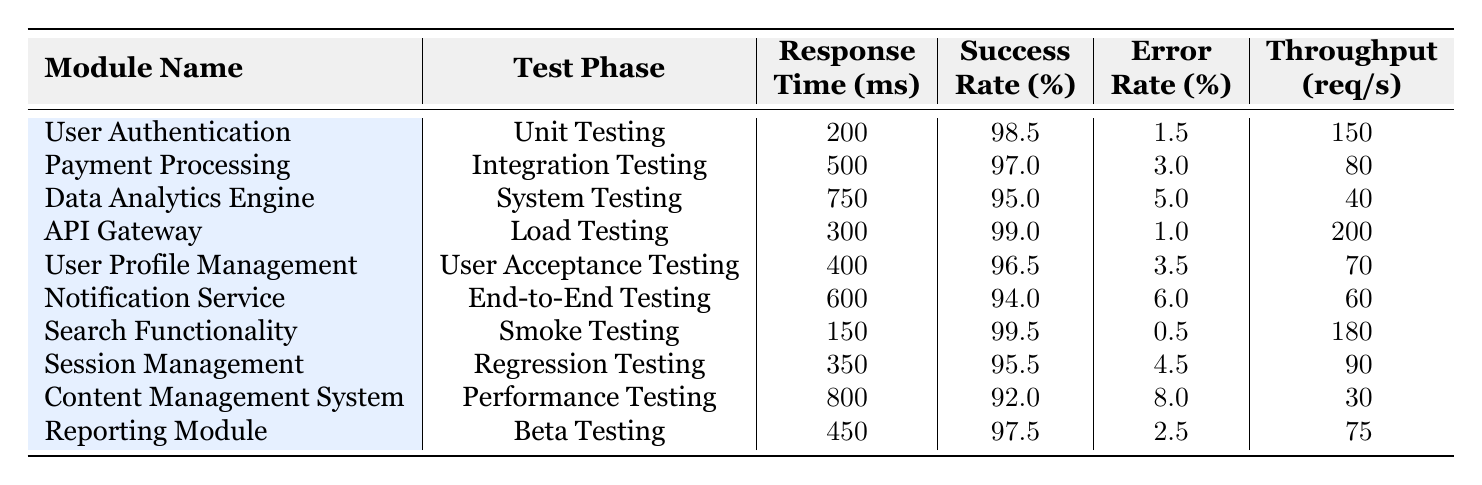What is the response time for the "Search Functionality" module during "Smoke Testing"? The table lists "Search Functionality" under the "Smoke Testing" phase with a response time of 150 ms.
Answer: 150 ms Which module has the highest success rate? By examining the success rates from each module, "Search Functionality" has the highest success rate at 99.5%.
Answer: 99.5% What is the error rate for the "Notification Service"? The table provides the error rate for "Notification Service," which is listed as 6.0%.
Answer: 6.0% Which test phase had the lowest throughput and what was that value? The table shows "Content Management System" during "Performance Testing" with the lowest throughput at 30 req/s.
Answer: 30 req/s What is the difference in success rate between the "User Authentication" and "Data Analytics Engine" modules? The success rate for "User Authentication" is 98.5% and for "Data Analytics Engine" it is 95.0%. The difference is 98.5% - 95.0% = 3.5%.
Answer: 3.5% Is the response time of "API Gateway" lower than the "Payment Processing" module? "API Gateway" has a response time of 300 ms, and "Payment Processing" has 500 ms. Since 300 ms is less than 500 ms, the answer is yes.
Answer: Yes What is the average response time across all modules? Sum the response times: (200 + 500 + 750 + 300 + 400 + 600 + 150 + 350 + 800 + 450) = 4050 ms. There are 10 modules so average = 4050 / 10 = 405 ms.
Answer: 405 ms During which test phase was the highest error rate observed, and what was that rate? The "Content Management System" during "Performance Testing" has the highest error rate of 8.0%, making it the highest observed.
Answer: 8.0% What module has the closest throughput to 100 req/s? The "Session Management" module has a throughput of 90 req/s, which is the closest to 100 req/s compared to others.
Answer: 90 req/s Is there any module that achieved a perfect success rate of 100%? Reviewing the success rates, no module shows a perfect success rate of 100%.
Answer: No 